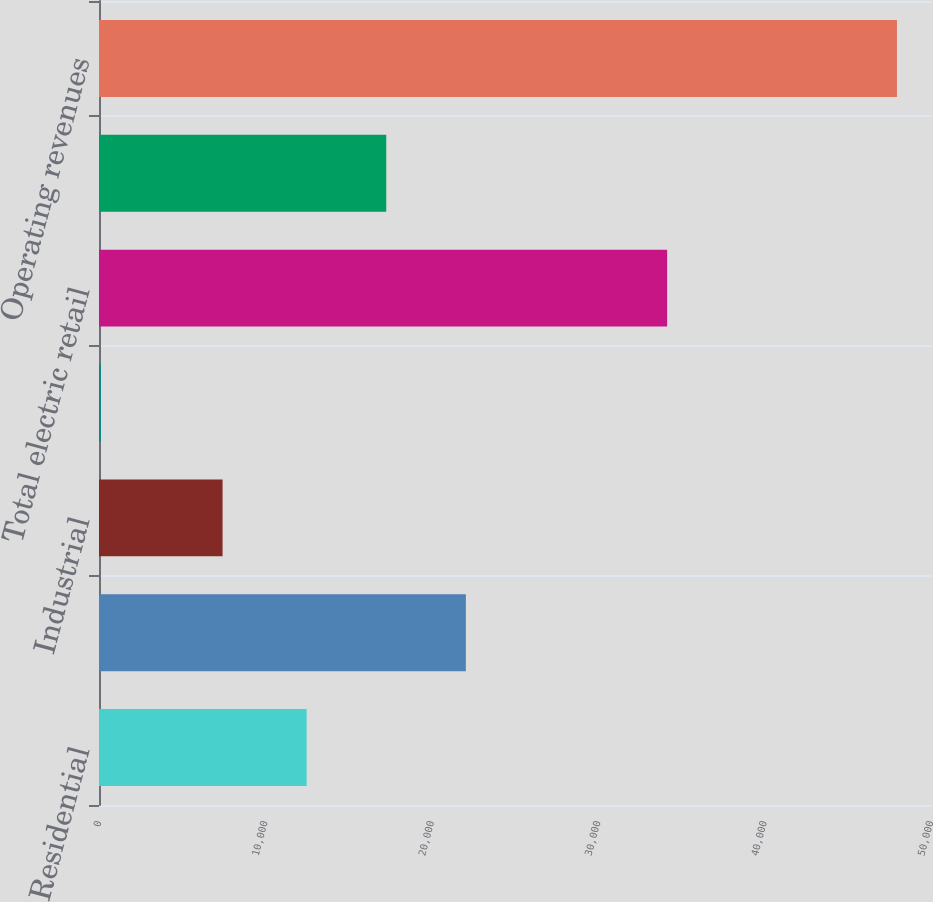Convert chart. <chart><loc_0><loc_0><loc_500><loc_500><bar_chart><fcel>Residential<fcel>Commercial<fcel>Industrial<fcel>Other retail revenues<fcel>Total electric retail<fcel>Wholesale revenues<fcel>Operating revenues<nl><fcel>12478<fcel>22046.8<fcel>7426<fcel>110<fcel>34143<fcel>17262.4<fcel>47954<nl></chart> 